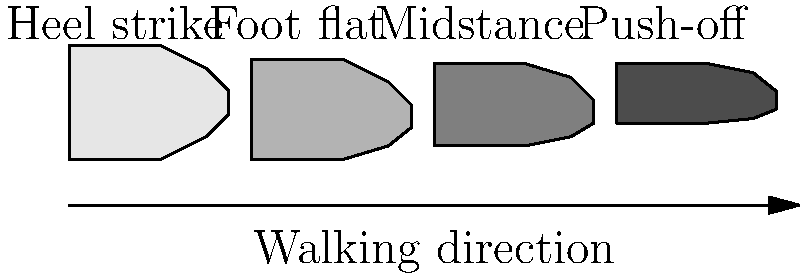During a heel-to-toe walking motion, at which phase of the gait cycle does the ankle joint experience the greatest dorsiflexion moment, and why is this biomechanically significant? To answer this question, let's break down the gait cycle and analyze the ankle joint's biomechanics:

1. Heel strike: The foot first contacts the ground with the heel. At this point, there's minimal dorsiflexion moment as the foot is just beginning to bear weight.

2. Foot flat: As the foot moves to a flat position, the ankle begins to dorsiflex to allow the tibia to move forward over the foot. However, the dorsiflexion moment is still relatively low.

3. Midstance: The body's center of mass passes over the supporting foot. The ankle continues to dorsiflex as the tibia moves forward, but the moment is not at its peak yet.

4. Push-off: This is where the ankle experiences the greatest dorsiflexion moment. As the heel begins to lift and the body's weight shifts onto the forefoot, the ankle must produce a strong plantarflexion force to propel the body forward. To counteract this, there's a significant dorsiflexion moment at the ankle.

The large dorsiflexion moment during push-off is biomechanically significant for several reasons:

a) It helps to stabilize the ankle joint as the body's weight shifts forward.
b) It allows for efficient energy transfer from the leg to the foot, contributing to forward propulsion.
c) It enables the ankle to act as a lever, multiplying the force generated by the calf muscles to create a powerful push-off.
d) It helps in maintaining balance and controlling the rate of forward progression of the tibia over the foot.

Understanding this biomechanical principle is crucial for physiotherapists in gait analysis, rehabilitation of ankle injuries, and designing exercises to improve ankle strength and stability.
Answer: Push-off phase; maximizes stability, energy transfer, and propulsion. 